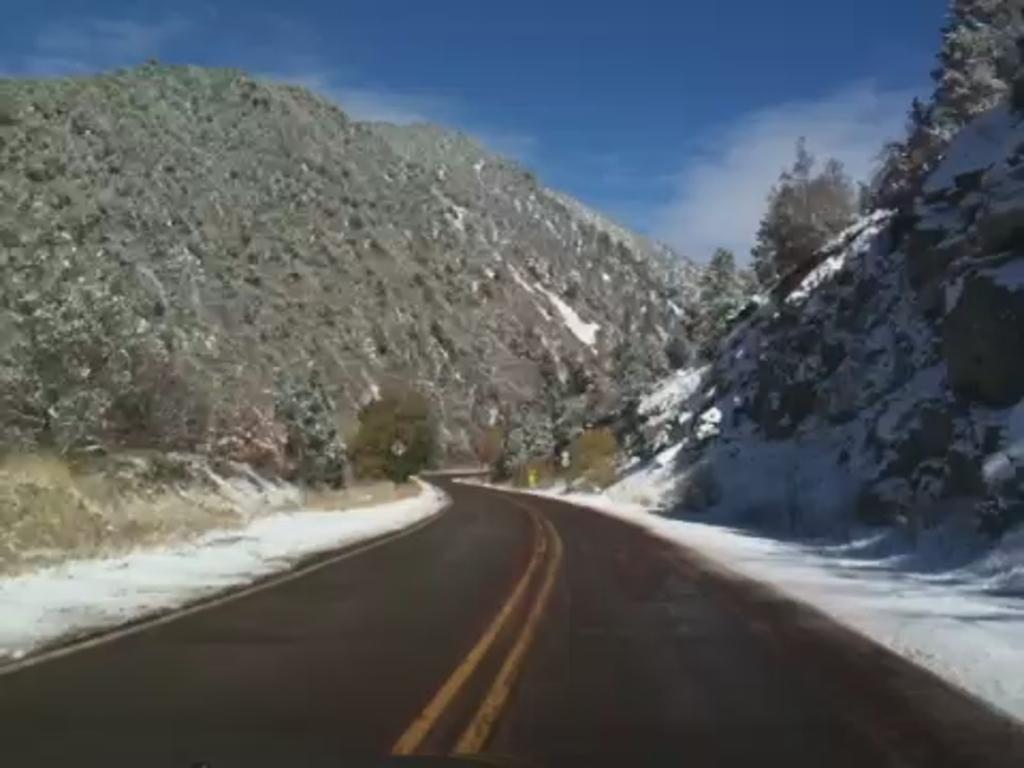Could you give a brief overview of what you see in this image? In this image, we can see mountains, trees and there is a board. At the top, there is sky and at the bottom, there is a road. 